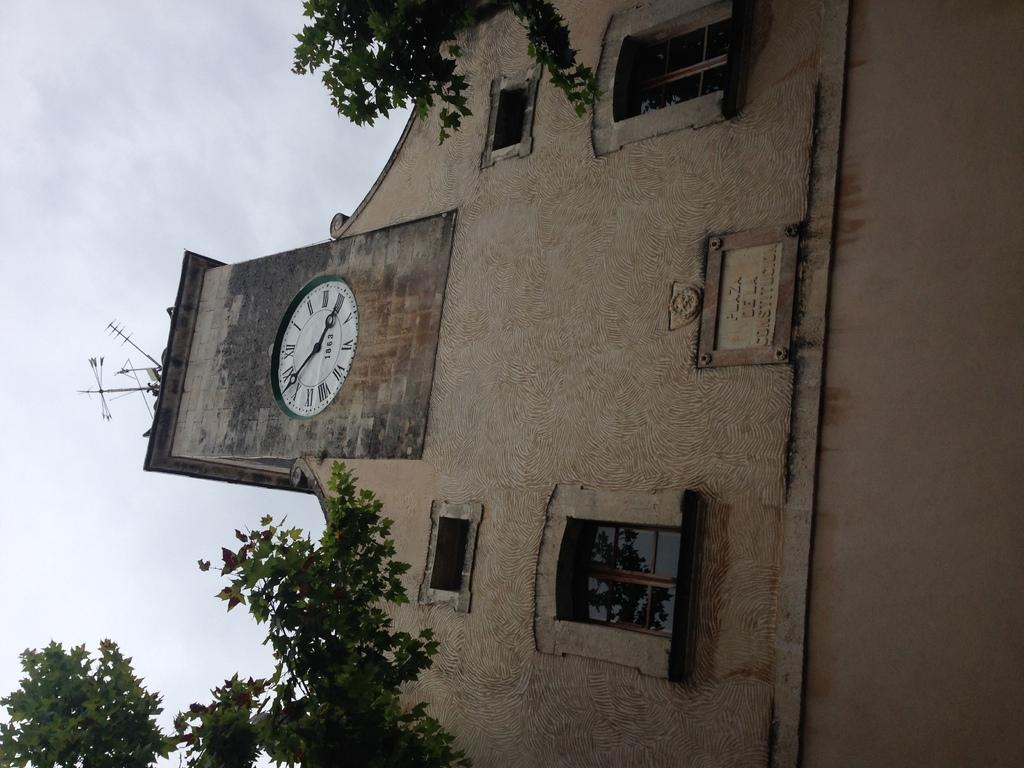<image>
Provide a brief description of the given image. A large building with a clock on the top as 1863 written on it 